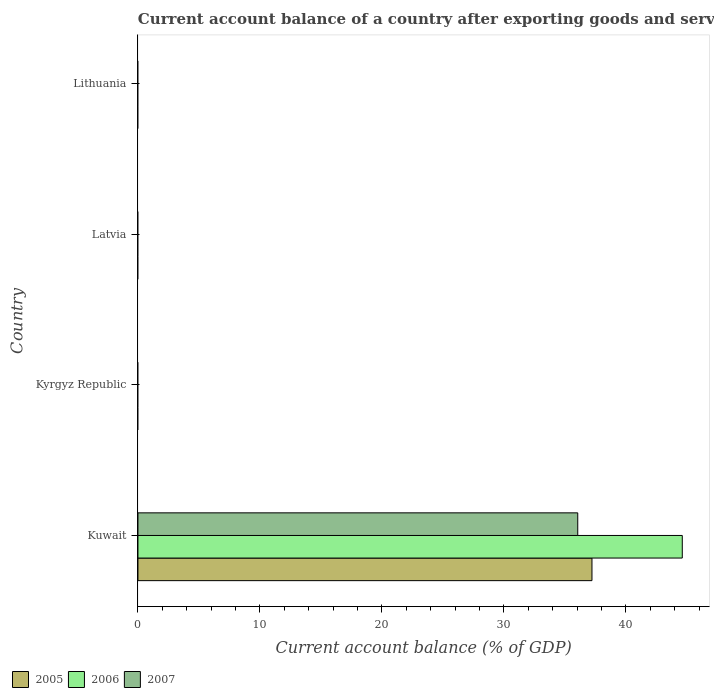How many bars are there on the 3rd tick from the bottom?
Offer a very short reply. 0. What is the label of the 3rd group of bars from the top?
Your answer should be very brief. Kyrgyz Republic. What is the account balance in 2005 in Lithuania?
Offer a very short reply. 0. Across all countries, what is the maximum account balance in 2006?
Your response must be concise. 44.62. In which country was the account balance in 2007 maximum?
Make the answer very short. Kuwait. What is the total account balance in 2007 in the graph?
Keep it short and to the point. 36.05. What is the difference between the account balance in 2006 in Kuwait and the account balance in 2007 in Lithuania?
Make the answer very short. 44.62. What is the average account balance in 2005 per country?
Your answer should be compact. 9.3. What is the difference between the account balance in 2007 and account balance in 2006 in Kuwait?
Keep it short and to the point. -8.57. What is the difference between the highest and the lowest account balance in 2007?
Ensure brevity in your answer.  36.05. Is it the case that in every country, the sum of the account balance in 2005 and account balance in 2006 is greater than the account balance in 2007?
Keep it short and to the point. No. How many bars are there?
Provide a short and direct response. 3. Are all the bars in the graph horizontal?
Keep it short and to the point. Yes. How many countries are there in the graph?
Your answer should be compact. 4. What is the difference between two consecutive major ticks on the X-axis?
Give a very brief answer. 10. Are the values on the major ticks of X-axis written in scientific E-notation?
Offer a very short reply. No. Where does the legend appear in the graph?
Keep it short and to the point. Bottom left. How are the legend labels stacked?
Provide a short and direct response. Horizontal. What is the title of the graph?
Offer a terse response. Current account balance of a country after exporting goods and services. What is the label or title of the X-axis?
Provide a succinct answer. Current account balance (% of GDP). What is the Current account balance (% of GDP) in 2005 in Kuwait?
Your answer should be very brief. 37.22. What is the Current account balance (% of GDP) of 2006 in Kuwait?
Give a very brief answer. 44.62. What is the Current account balance (% of GDP) in 2007 in Kuwait?
Offer a terse response. 36.05. What is the Current account balance (% of GDP) in 2005 in Kyrgyz Republic?
Provide a short and direct response. 0. What is the Current account balance (% of GDP) of 2007 in Kyrgyz Republic?
Make the answer very short. 0. What is the Current account balance (% of GDP) in 2005 in Latvia?
Offer a terse response. 0. What is the Current account balance (% of GDP) of 2006 in Latvia?
Offer a terse response. 0. What is the Current account balance (% of GDP) in 2007 in Latvia?
Offer a very short reply. 0. What is the Current account balance (% of GDP) of 2006 in Lithuania?
Provide a succinct answer. 0. Across all countries, what is the maximum Current account balance (% of GDP) in 2005?
Provide a succinct answer. 37.22. Across all countries, what is the maximum Current account balance (% of GDP) in 2006?
Provide a succinct answer. 44.62. Across all countries, what is the maximum Current account balance (% of GDP) in 2007?
Your answer should be very brief. 36.05. Across all countries, what is the minimum Current account balance (% of GDP) in 2005?
Your answer should be compact. 0. Across all countries, what is the minimum Current account balance (% of GDP) in 2007?
Your response must be concise. 0. What is the total Current account balance (% of GDP) of 2005 in the graph?
Offer a very short reply. 37.22. What is the total Current account balance (% of GDP) in 2006 in the graph?
Your response must be concise. 44.62. What is the total Current account balance (% of GDP) in 2007 in the graph?
Your response must be concise. 36.05. What is the average Current account balance (% of GDP) of 2005 per country?
Your answer should be compact. 9.3. What is the average Current account balance (% of GDP) of 2006 per country?
Make the answer very short. 11.15. What is the average Current account balance (% of GDP) of 2007 per country?
Keep it short and to the point. 9.01. What is the difference between the Current account balance (% of GDP) in 2005 and Current account balance (% of GDP) in 2006 in Kuwait?
Provide a succinct answer. -7.4. What is the difference between the Current account balance (% of GDP) in 2005 and Current account balance (% of GDP) in 2007 in Kuwait?
Your answer should be compact. 1.17. What is the difference between the Current account balance (% of GDP) of 2006 and Current account balance (% of GDP) of 2007 in Kuwait?
Offer a very short reply. 8.57. What is the difference between the highest and the lowest Current account balance (% of GDP) of 2005?
Offer a very short reply. 37.22. What is the difference between the highest and the lowest Current account balance (% of GDP) of 2006?
Your answer should be very brief. 44.62. What is the difference between the highest and the lowest Current account balance (% of GDP) in 2007?
Offer a terse response. 36.05. 